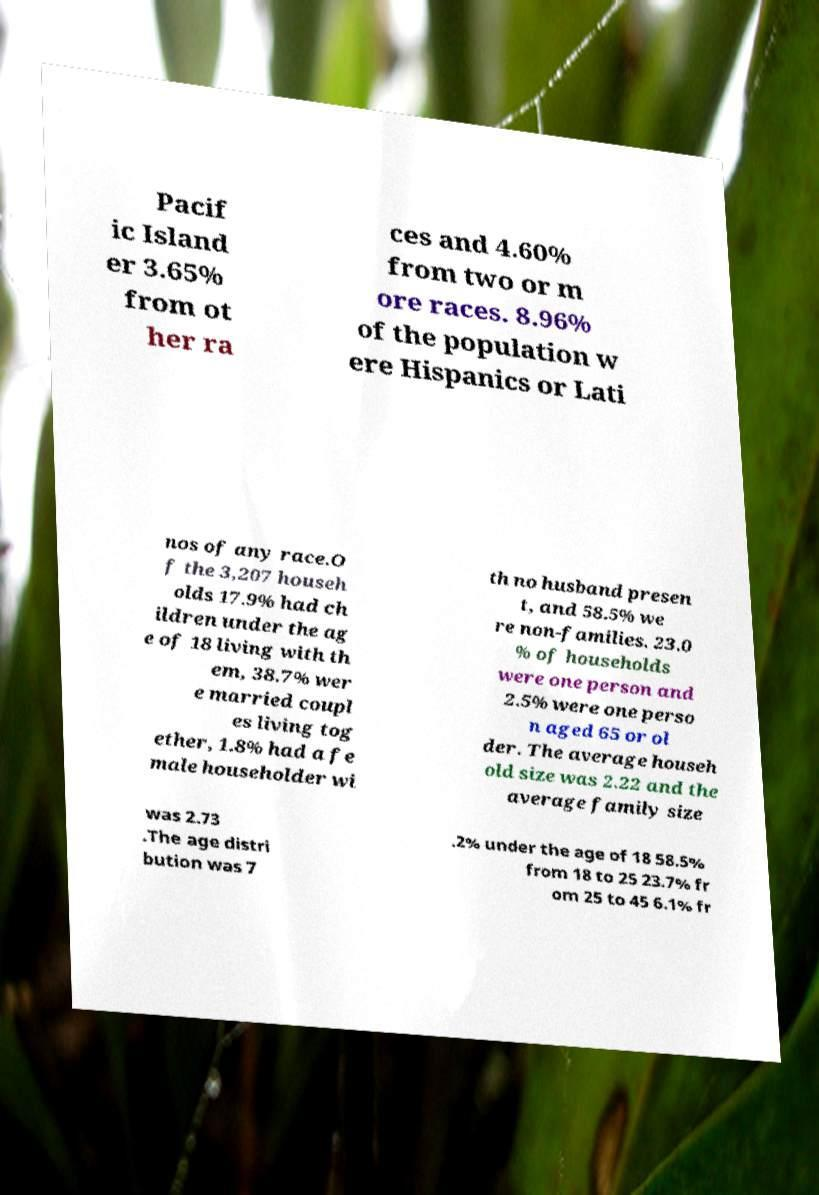Could you extract and type out the text from this image? Pacif ic Island er 3.65% from ot her ra ces and 4.60% from two or m ore races. 8.96% of the population w ere Hispanics or Lati nos of any race.O f the 3,207 househ olds 17.9% had ch ildren under the ag e of 18 living with th em, 38.7% wer e married coupl es living tog ether, 1.8% had a fe male householder wi th no husband presen t, and 58.5% we re non-families. 23.0 % of households were one person and 2.5% were one perso n aged 65 or ol der. The average househ old size was 2.22 and the average family size was 2.73 .The age distri bution was 7 .2% under the age of 18 58.5% from 18 to 25 23.7% fr om 25 to 45 6.1% fr 